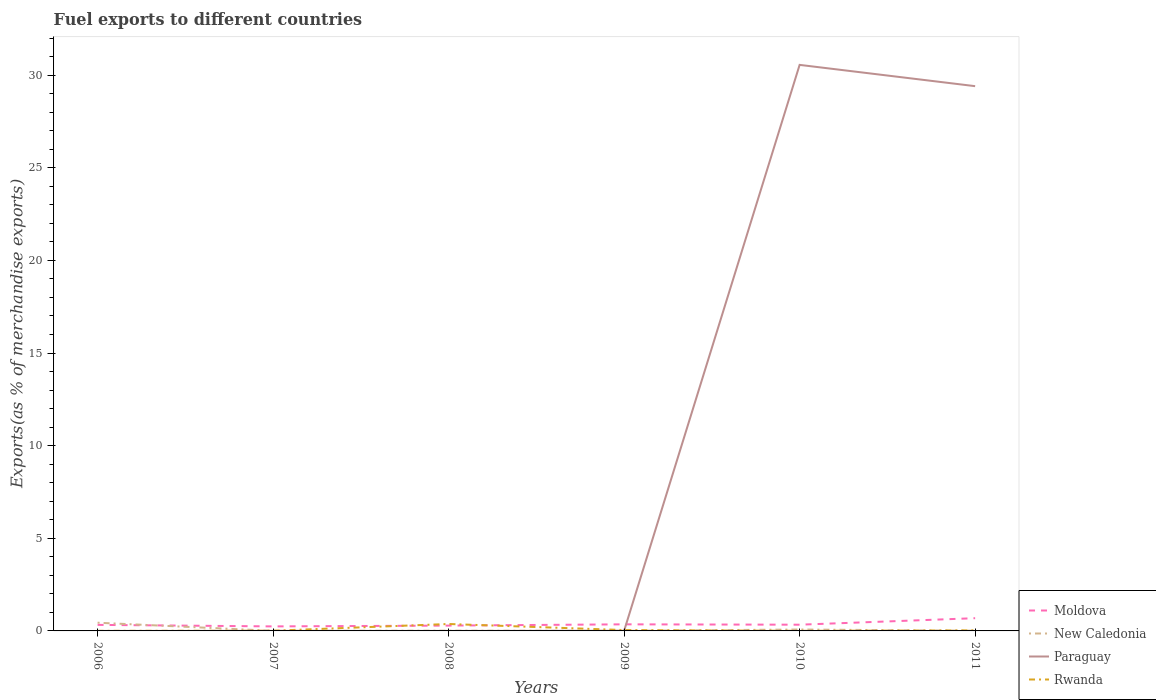Across all years, what is the maximum percentage of exports to different countries in New Caledonia?
Your answer should be compact. 0. What is the total percentage of exports to different countries in New Caledonia in the graph?
Keep it short and to the point. -0.07. What is the difference between the highest and the second highest percentage of exports to different countries in New Caledonia?
Your answer should be compact. 0.44. What is the difference between the highest and the lowest percentage of exports to different countries in Paraguay?
Ensure brevity in your answer.  2. How many lines are there?
Ensure brevity in your answer.  4. How many years are there in the graph?
Your answer should be very brief. 6. What is the difference between two consecutive major ticks on the Y-axis?
Your response must be concise. 5. Does the graph contain grids?
Keep it short and to the point. No. How many legend labels are there?
Your response must be concise. 4. How are the legend labels stacked?
Offer a very short reply. Vertical. What is the title of the graph?
Keep it short and to the point. Fuel exports to different countries. What is the label or title of the X-axis?
Your answer should be very brief. Years. What is the label or title of the Y-axis?
Your response must be concise. Exports(as % of merchandise exports). What is the Exports(as % of merchandise exports) of Moldova in 2006?
Ensure brevity in your answer.  0.33. What is the Exports(as % of merchandise exports) in New Caledonia in 2006?
Give a very brief answer. 0.44. What is the Exports(as % of merchandise exports) in Paraguay in 2006?
Provide a succinct answer. 1.68181738458249e-6. What is the Exports(as % of merchandise exports) of Rwanda in 2006?
Give a very brief answer. 0. What is the Exports(as % of merchandise exports) of Moldova in 2007?
Offer a very short reply. 0.24. What is the Exports(as % of merchandise exports) in New Caledonia in 2007?
Make the answer very short. 0.01. What is the Exports(as % of merchandise exports) in Paraguay in 2007?
Your answer should be compact. 0. What is the Exports(as % of merchandise exports) in Rwanda in 2007?
Give a very brief answer. 0.01. What is the Exports(as % of merchandise exports) of Moldova in 2008?
Ensure brevity in your answer.  0.29. What is the Exports(as % of merchandise exports) of New Caledonia in 2008?
Your answer should be compact. 0.01. What is the Exports(as % of merchandise exports) in Paraguay in 2008?
Keep it short and to the point. 0. What is the Exports(as % of merchandise exports) in Rwanda in 2008?
Offer a very short reply. 0.37. What is the Exports(as % of merchandise exports) of Moldova in 2009?
Provide a succinct answer. 0.36. What is the Exports(as % of merchandise exports) of New Caledonia in 2009?
Keep it short and to the point. 0. What is the Exports(as % of merchandise exports) of Paraguay in 2009?
Your answer should be compact. 0.01. What is the Exports(as % of merchandise exports) in Rwanda in 2009?
Offer a terse response. 0.05. What is the Exports(as % of merchandise exports) of Moldova in 2010?
Make the answer very short. 0.34. What is the Exports(as % of merchandise exports) in New Caledonia in 2010?
Offer a terse response. 0.08. What is the Exports(as % of merchandise exports) in Paraguay in 2010?
Offer a terse response. 30.55. What is the Exports(as % of merchandise exports) of Rwanda in 2010?
Your answer should be compact. 0.01. What is the Exports(as % of merchandise exports) in Moldova in 2011?
Give a very brief answer. 0.69. What is the Exports(as % of merchandise exports) of New Caledonia in 2011?
Make the answer very short. 0.01. What is the Exports(as % of merchandise exports) in Paraguay in 2011?
Offer a very short reply. 29.4. What is the Exports(as % of merchandise exports) of Rwanda in 2011?
Provide a short and direct response. 0.03. Across all years, what is the maximum Exports(as % of merchandise exports) of Moldova?
Keep it short and to the point. 0.69. Across all years, what is the maximum Exports(as % of merchandise exports) in New Caledonia?
Provide a succinct answer. 0.44. Across all years, what is the maximum Exports(as % of merchandise exports) in Paraguay?
Your answer should be compact. 30.55. Across all years, what is the maximum Exports(as % of merchandise exports) of Rwanda?
Ensure brevity in your answer.  0.37. Across all years, what is the minimum Exports(as % of merchandise exports) of Moldova?
Make the answer very short. 0.24. Across all years, what is the minimum Exports(as % of merchandise exports) of New Caledonia?
Keep it short and to the point. 0. Across all years, what is the minimum Exports(as % of merchandise exports) of Paraguay?
Give a very brief answer. 1.68181738458249e-6. Across all years, what is the minimum Exports(as % of merchandise exports) of Rwanda?
Your response must be concise. 0. What is the total Exports(as % of merchandise exports) in Moldova in the graph?
Your answer should be very brief. 2.24. What is the total Exports(as % of merchandise exports) of New Caledonia in the graph?
Ensure brevity in your answer.  0.55. What is the total Exports(as % of merchandise exports) in Paraguay in the graph?
Give a very brief answer. 59.96. What is the total Exports(as % of merchandise exports) in Rwanda in the graph?
Give a very brief answer. 0.47. What is the difference between the Exports(as % of merchandise exports) in Moldova in 2006 and that in 2007?
Offer a very short reply. 0.08. What is the difference between the Exports(as % of merchandise exports) of New Caledonia in 2006 and that in 2007?
Offer a terse response. 0.44. What is the difference between the Exports(as % of merchandise exports) in Paraguay in 2006 and that in 2007?
Your answer should be compact. -0. What is the difference between the Exports(as % of merchandise exports) of Rwanda in 2006 and that in 2007?
Ensure brevity in your answer.  -0.01. What is the difference between the Exports(as % of merchandise exports) of Moldova in 2006 and that in 2008?
Offer a terse response. 0.04. What is the difference between the Exports(as % of merchandise exports) of New Caledonia in 2006 and that in 2008?
Provide a short and direct response. 0.43. What is the difference between the Exports(as % of merchandise exports) of Paraguay in 2006 and that in 2008?
Give a very brief answer. -0. What is the difference between the Exports(as % of merchandise exports) of Rwanda in 2006 and that in 2008?
Provide a succinct answer. -0.37. What is the difference between the Exports(as % of merchandise exports) in Moldova in 2006 and that in 2009?
Your answer should be very brief. -0.03. What is the difference between the Exports(as % of merchandise exports) of New Caledonia in 2006 and that in 2009?
Keep it short and to the point. 0.44. What is the difference between the Exports(as % of merchandise exports) of Paraguay in 2006 and that in 2009?
Your answer should be compact. -0.01. What is the difference between the Exports(as % of merchandise exports) of Rwanda in 2006 and that in 2009?
Give a very brief answer. -0.04. What is the difference between the Exports(as % of merchandise exports) of Moldova in 2006 and that in 2010?
Your answer should be compact. -0.01. What is the difference between the Exports(as % of merchandise exports) of New Caledonia in 2006 and that in 2010?
Keep it short and to the point. 0.37. What is the difference between the Exports(as % of merchandise exports) of Paraguay in 2006 and that in 2010?
Your answer should be compact. -30.55. What is the difference between the Exports(as % of merchandise exports) of Rwanda in 2006 and that in 2010?
Your response must be concise. -0. What is the difference between the Exports(as % of merchandise exports) of Moldova in 2006 and that in 2011?
Offer a very short reply. -0.36. What is the difference between the Exports(as % of merchandise exports) of New Caledonia in 2006 and that in 2011?
Your answer should be very brief. 0.43. What is the difference between the Exports(as % of merchandise exports) in Paraguay in 2006 and that in 2011?
Provide a short and direct response. -29.4. What is the difference between the Exports(as % of merchandise exports) of Rwanda in 2006 and that in 2011?
Offer a very short reply. -0.03. What is the difference between the Exports(as % of merchandise exports) in Moldova in 2007 and that in 2008?
Your answer should be very brief. -0.04. What is the difference between the Exports(as % of merchandise exports) of New Caledonia in 2007 and that in 2008?
Ensure brevity in your answer.  -0.01. What is the difference between the Exports(as % of merchandise exports) in Paraguay in 2007 and that in 2008?
Provide a succinct answer. 0. What is the difference between the Exports(as % of merchandise exports) in Rwanda in 2007 and that in 2008?
Ensure brevity in your answer.  -0.36. What is the difference between the Exports(as % of merchandise exports) in Moldova in 2007 and that in 2009?
Your response must be concise. -0.11. What is the difference between the Exports(as % of merchandise exports) of New Caledonia in 2007 and that in 2009?
Offer a terse response. 0. What is the difference between the Exports(as % of merchandise exports) in Paraguay in 2007 and that in 2009?
Give a very brief answer. -0.01. What is the difference between the Exports(as % of merchandise exports) in Rwanda in 2007 and that in 2009?
Offer a very short reply. -0.04. What is the difference between the Exports(as % of merchandise exports) in Moldova in 2007 and that in 2010?
Your response must be concise. -0.09. What is the difference between the Exports(as % of merchandise exports) in New Caledonia in 2007 and that in 2010?
Make the answer very short. -0.07. What is the difference between the Exports(as % of merchandise exports) in Paraguay in 2007 and that in 2010?
Offer a terse response. -30.55. What is the difference between the Exports(as % of merchandise exports) of Rwanda in 2007 and that in 2010?
Your answer should be compact. 0.01. What is the difference between the Exports(as % of merchandise exports) of Moldova in 2007 and that in 2011?
Your answer should be compact. -0.44. What is the difference between the Exports(as % of merchandise exports) in New Caledonia in 2007 and that in 2011?
Offer a very short reply. -0.01. What is the difference between the Exports(as % of merchandise exports) in Paraguay in 2007 and that in 2011?
Make the answer very short. -29.4. What is the difference between the Exports(as % of merchandise exports) in Rwanda in 2007 and that in 2011?
Provide a succinct answer. -0.02. What is the difference between the Exports(as % of merchandise exports) in Moldova in 2008 and that in 2009?
Your response must be concise. -0.07. What is the difference between the Exports(as % of merchandise exports) in New Caledonia in 2008 and that in 2009?
Offer a terse response. 0.01. What is the difference between the Exports(as % of merchandise exports) of Paraguay in 2008 and that in 2009?
Your answer should be compact. -0.01. What is the difference between the Exports(as % of merchandise exports) of Rwanda in 2008 and that in 2009?
Offer a very short reply. 0.33. What is the difference between the Exports(as % of merchandise exports) in Moldova in 2008 and that in 2010?
Your answer should be very brief. -0.05. What is the difference between the Exports(as % of merchandise exports) of New Caledonia in 2008 and that in 2010?
Give a very brief answer. -0.07. What is the difference between the Exports(as % of merchandise exports) in Paraguay in 2008 and that in 2010?
Your response must be concise. -30.55. What is the difference between the Exports(as % of merchandise exports) in Rwanda in 2008 and that in 2010?
Your answer should be very brief. 0.37. What is the difference between the Exports(as % of merchandise exports) of Moldova in 2008 and that in 2011?
Provide a short and direct response. -0.4. What is the difference between the Exports(as % of merchandise exports) in New Caledonia in 2008 and that in 2011?
Your answer should be very brief. 0. What is the difference between the Exports(as % of merchandise exports) of Paraguay in 2008 and that in 2011?
Make the answer very short. -29.4. What is the difference between the Exports(as % of merchandise exports) of Rwanda in 2008 and that in 2011?
Provide a succinct answer. 0.34. What is the difference between the Exports(as % of merchandise exports) in Moldova in 2009 and that in 2010?
Give a very brief answer. 0.02. What is the difference between the Exports(as % of merchandise exports) of New Caledonia in 2009 and that in 2010?
Make the answer very short. -0.07. What is the difference between the Exports(as % of merchandise exports) in Paraguay in 2009 and that in 2010?
Keep it short and to the point. -30.54. What is the difference between the Exports(as % of merchandise exports) in Rwanda in 2009 and that in 2010?
Offer a very short reply. 0.04. What is the difference between the Exports(as % of merchandise exports) in Moldova in 2009 and that in 2011?
Ensure brevity in your answer.  -0.33. What is the difference between the Exports(as % of merchandise exports) of New Caledonia in 2009 and that in 2011?
Ensure brevity in your answer.  -0.01. What is the difference between the Exports(as % of merchandise exports) of Paraguay in 2009 and that in 2011?
Ensure brevity in your answer.  -29.39. What is the difference between the Exports(as % of merchandise exports) of Rwanda in 2009 and that in 2011?
Offer a terse response. 0.02. What is the difference between the Exports(as % of merchandise exports) in Moldova in 2010 and that in 2011?
Give a very brief answer. -0.35. What is the difference between the Exports(as % of merchandise exports) in New Caledonia in 2010 and that in 2011?
Offer a terse response. 0.07. What is the difference between the Exports(as % of merchandise exports) of Paraguay in 2010 and that in 2011?
Provide a short and direct response. 1.15. What is the difference between the Exports(as % of merchandise exports) in Rwanda in 2010 and that in 2011?
Your answer should be very brief. -0.03. What is the difference between the Exports(as % of merchandise exports) of Moldova in 2006 and the Exports(as % of merchandise exports) of New Caledonia in 2007?
Offer a terse response. 0.32. What is the difference between the Exports(as % of merchandise exports) of Moldova in 2006 and the Exports(as % of merchandise exports) of Paraguay in 2007?
Your answer should be compact. 0.33. What is the difference between the Exports(as % of merchandise exports) in Moldova in 2006 and the Exports(as % of merchandise exports) in Rwanda in 2007?
Provide a short and direct response. 0.32. What is the difference between the Exports(as % of merchandise exports) in New Caledonia in 2006 and the Exports(as % of merchandise exports) in Paraguay in 2007?
Your answer should be compact. 0.44. What is the difference between the Exports(as % of merchandise exports) in New Caledonia in 2006 and the Exports(as % of merchandise exports) in Rwanda in 2007?
Ensure brevity in your answer.  0.43. What is the difference between the Exports(as % of merchandise exports) in Paraguay in 2006 and the Exports(as % of merchandise exports) in Rwanda in 2007?
Your answer should be very brief. -0.01. What is the difference between the Exports(as % of merchandise exports) of Moldova in 2006 and the Exports(as % of merchandise exports) of New Caledonia in 2008?
Make the answer very short. 0.32. What is the difference between the Exports(as % of merchandise exports) in Moldova in 2006 and the Exports(as % of merchandise exports) in Paraguay in 2008?
Give a very brief answer. 0.33. What is the difference between the Exports(as % of merchandise exports) in Moldova in 2006 and the Exports(as % of merchandise exports) in Rwanda in 2008?
Your answer should be compact. -0.05. What is the difference between the Exports(as % of merchandise exports) in New Caledonia in 2006 and the Exports(as % of merchandise exports) in Paraguay in 2008?
Offer a terse response. 0.44. What is the difference between the Exports(as % of merchandise exports) in New Caledonia in 2006 and the Exports(as % of merchandise exports) in Rwanda in 2008?
Your answer should be very brief. 0.07. What is the difference between the Exports(as % of merchandise exports) of Paraguay in 2006 and the Exports(as % of merchandise exports) of Rwanda in 2008?
Provide a short and direct response. -0.37. What is the difference between the Exports(as % of merchandise exports) in Moldova in 2006 and the Exports(as % of merchandise exports) in New Caledonia in 2009?
Your response must be concise. 0.32. What is the difference between the Exports(as % of merchandise exports) of Moldova in 2006 and the Exports(as % of merchandise exports) of Paraguay in 2009?
Your answer should be compact. 0.32. What is the difference between the Exports(as % of merchandise exports) in Moldova in 2006 and the Exports(as % of merchandise exports) in Rwanda in 2009?
Your answer should be compact. 0.28. What is the difference between the Exports(as % of merchandise exports) in New Caledonia in 2006 and the Exports(as % of merchandise exports) in Paraguay in 2009?
Offer a terse response. 0.43. What is the difference between the Exports(as % of merchandise exports) in New Caledonia in 2006 and the Exports(as % of merchandise exports) in Rwanda in 2009?
Offer a very short reply. 0.4. What is the difference between the Exports(as % of merchandise exports) of Paraguay in 2006 and the Exports(as % of merchandise exports) of Rwanda in 2009?
Your response must be concise. -0.05. What is the difference between the Exports(as % of merchandise exports) of Moldova in 2006 and the Exports(as % of merchandise exports) of New Caledonia in 2010?
Offer a very short reply. 0.25. What is the difference between the Exports(as % of merchandise exports) in Moldova in 2006 and the Exports(as % of merchandise exports) in Paraguay in 2010?
Provide a short and direct response. -30.22. What is the difference between the Exports(as % of merchandise exports) in Moldova in 2006 and the Exports(as % of merchandise exports) in Rwanda in 2010?
Give a very brief answer. 0.32. What is the difference between the Exports(as % of merchandise exports) of New Caledonia in 2006 and the Exports(as % of merchandise exports) of Paraguay in 2010?
Offer a terse response. -30.11. What is the difference between the Exports(as % of merchandise exports) in New Caledonia in 2006 and the Exports(as % of merchandise exports) in Rwanda in 2010?
Make the answer very short. 0.44. What is the difference between the Exports(as % of merchandise exports) in Paraguay in 2006 and the Exports(as % of merchandise exports) in Rwanda in 2010?
Your answer should be very brief. -0.01. What is the difference between the Exports(as % of merchandise exports) in Moldova in 2006 and the Exports(as % of merchandise exports) in New Caledonia in 2011?
Your answer should be compact. 0.32. What is the difference between the Exports(as % of merchandise exports) of Moldova in 2006 and the Exports(as % of merchandise exports) of Paraguay in 2011?
Your answer should be compact. -29.08. What is the difference between the Exports(as % of merchandise exports) of Moldova in 2006 and the Exports(as % of merchandise exports) of Rwanda in 2011?
Offer a very short reply. 0.3. What is the difference between the Exports(as % of merchandise exports) in New Caledonia in 2006 and the Exports(as % of merchandise exports) in Paraguay in 2011?
Your response must be concise. -28.96. What is the difference between the Exports(as % of merchandise exports) in New Caledonia in 2006 and the Exports(as % of merchandise exports) in Rwanda in 2011?
Give a very brief answer. 0.41. What is the difference between the Exports(as % of merchandise exports) of Paraguay in 2006 and the Exports(as % of merchandise exports) of Rwanda in 2011?
Provide a succinct answer. -0.03. What is the difference between the Exports(as % of merchandise exports) of Moldova in 2007 and the Exports(as % of merchandise exports) of New Caledonia in 2008?
Make the answer very short. 0.23. What is the difference between the Exports(as % of merchandise exports) of Moldova in 2007 and the Exports(as % of merchandise exports) of Paraguay in 2008?
Make the answer very short. 0.24. What is the difference between the Exports(as % of merchandise exports) of Moldova in 2007 and the Exports(as % of merchandise exports) of Rwanda in 2008?
Ensure brevity in your answer.  -0.13. What is the difference between the Exports(as % of merchandise exports) of New Caledonia in 2007 and the Exports(as % of merchandise exports) of Paraguay in 2008?
Provide a short and direct response. 0.01. What is the difference between the Exports(as % of merchandise exports) in New Caledonia in 2007 and the Exports(as % of merchandise exports) in Rwanda in 2008?
Keep it short and to the point. -0.37. What is the difference between the Exports(as % of merchandise exports) in Paraguay in 2007 and the Exports(as % of merchandise exports) in Rwanda in 2008?
Offer a terse response. -0.37. What is the difference between the Exports(as % of merchandise exports) in Moldova in 2007 and the Exports(as % of merchandise exports) in New Caledonia in 2009?
Keep it short and to the point. 0.24. What is the difference between the Exports(as % of merchandise exports) in Moldova in 2007 and the Exports(as % of merchandise exports) in Paraguay in 2009?
Offer a terse response. 0.24. What is the difference between the Exports(as % of merchandise exports) of Moldova in 2007 and the Exports(as % of merchandise exports) of Rwanda in 2009?
Make the answer very short. 0.2. What is the difference between the Exports(as % of merchandise exports) in New Caledonia in 2007 and the Exports(as % of merchandise exports) in Paraguay in 2009?
Your response must be concise. -0. What is the difference between the Exports(as % of merchandise exports) of New Caledonia in 2007 and the Exports(as % of merchandise exports) of Rwanda in 2009?
Ensure brevity in your answer.  -0.04. What is the difference between the Exports(as % of merchandise exports) in Paraguay in 2007 and the Exports(as % of merchandise exports) in Rwanda in 2009?
Provide a succinct answer. -0.05. What is the difference between the Exports(as % of merchandise exports) of Moldova in 2007 and the Exports(as % of merchandise exports) of New Caledonia in 2010?
Provide a short and direct response. 0.17. What is the difference between the Exports(as % of merchandise exports) of Moldova in 2007 and the Exports(as % of merchandise exports) of Paraguay in 2010?
Ensure brevity in your answer.  -30.31. What is the difference between the Exports(as % of merchandise exports) in Moldova in 2007 and the Exports(as % of merchandise exports) in Rwanda in 2010?
Keep it short and to the point. 0.24. What is the difference between the Exports(as % of merchandise exports) of New Caledonia in 2007 and the Exports(as % of merchandise exports) of Paraguay in 2010?
Your answer should be compact. -30.55. What is the difference between the Exports(as % of merchandise exports) in New Caledonia in 2007 and the Exports(as % of merchandise exports) in Rwanda in 2010?
Offer a very short reply. -0. What is the difference between the Exports(as % of merchandise exports) of Paraguay in 2007 and the Exports(as % of merchandise exports) of Rwanda in 2010?
Your answer should be compact. -0. What is the difference between the Exports(as % of merchandise exports) of Moldova in 2007 and the Exports(as % of merchandise exports) of New Caledonia in 2011?
Provide a short and direct response. 0.23. What is the difference between the Exports(as % of merchandise exports) of Moldova in 2007 and the Exports(as % of merchandise exports) of Paraguay in 2011?
Make the answer very short. -29.16. What is the difference between the Exports(as % of merchandise exports) of Moldova in 2007 and the Exports(as % of merchandise exports) of Rwanda in 2011?
Keep it short and to the point. 0.21. What is the difference between the Exports(as % of merchandise exports) of New Caledonia in 2007 and the Exports(as % of merchandise exports) of Paraguay in 2011?
Ensure brevity in your answer.  -29.4. What is the difference between the Exports(as % of merchandise exports) of New Caledonia in 2007 and the Exports(as % of merchandise exports) of Rwanda in 2011?
Your answer should be compact. -0.03. What is the difference between the Exports(as % of merchandise exports) in Paraguay in 2007 and the Exports(as % of merchandise exports) in Rwanda in 2011?
Offer a terse response. -0.03. What is the difference between the Exports(as % of merchandise exports) in Moldova in 2008 and the Exports(as % of merchandise exports) in New Caledonia in 2009?
Your answer should be compact. 0.28. What is the difference between the Exports(as % of merchandise exports) in Moldova in 2008 and the Exports(as % of merchandise exports) in Paraguay in 2009?
Provide a short and direct response. 0.28. What is the difference between the Exports(as % of merchandise exports) of Moldova in 2008 and the Exports(as % of merchandise exports) of Rwanda in 2009?
Keep it short and to the point. 0.24. What is the difference between the Exports(as % of merchandise exports) in New Caledonia in 2008 and the Exports(as % of merchandise exports) in Paraguay in 2009?
Make the answer very short. 0. What is the difference between the Exports(as % of merchandise exports) of New Caledonia in 2008 and the Exports(as % of merchandise exports) of Rwanda in 2009?
Offer a terse response. -0.04. What is the difference between the Exports(as % of merchandise exports) of Paraguay in 2008 and the Exports(as % of merchandise exports) of Rwanda in 2009?
Provide a succinct answer. -0.05. What is the difference between the Exports(as % of merchandise exports) of Moldova in 2008 and the Exports(as % of merchandise exports) of New Caledonia in 2010?
Your answer should be compact. 0.21. What is the difference between the Exports(as % of merchandise exports) in Moldova in 2008 and the Exports(as % of merchandise exports) in Paraguay in 2010?
Your answer should be very brief. -30.26. What is the difference between the Exports(as % of merchandise exports) of Moldova in 2008 and the Exports(as % of merchandise exports) of Rwanda in 2010?
Give a very brief answer. 0.28. What is the difference between the Exports(as % of merchandise exports) in New Caledonia in 2008 and the Exports(as % of merchandise exports) in Paraguay in 2010?
Your answer should be very brief. -30.54. What is the difference between the Exports(as % of merchandise exports) in New Caledonia in 2008 and the Exports(as % of merchandise exports) in Rwanda in 2010?
Make the answer very short. 0.01. What is the difference between the Exports(as % of merchandise exports) of Paraguay in 2008 and the Exports(as % of merchandise exports) of Rwanda in 2010?
Ensure brevity in your answer.  -0.01. What is the difference between the Exports(as % of merchandise exports) of Moldova in 2008 and the Exports(as % of merchandise exports) of New Caledonia in 2011?
Your response must be concise. 0.28. What is the difference between the Exports(as % of merchandise exports) in Moldova in 2008 and the Exports(as % of merchandise exports) in Paraguay in 2011?
Your answer should be very brief. -29.11. What is the difference between the Exports(as % of merchandise exports) of Moldova in 2008 and the Exports(as % of merchandise exports) of Rwanda in 2011?
Give a very brief answer. 0.26. What is the difference between the Exports(as % of merchandise exports) in New Caledonia in 2008 and the Exports(as % of merchandise exports) in Paraguay in 2011?
Your answer should be very brief. -29.39. What is the difference between the Exports(as % of merchandise exports) in New Caledonia in 2008 and the Exports(as % of merchandise exports) in Rwanda in 2011?
Give a very brief answer. -0.02. What is the difference between the Exports(as % of merchandise exports) in Paraguay in 2008 and the Exports(as % of merchandise exports) in Rwanda in 2011?
Provide a short and direct response. -0.03. What is the difference between the Exports(as % of merchandise exports) of Moldova in 2009 and the Exports(as % of merchandise exports) of New Caledonia in 2010?
Provide a succinct answer. 0.28. What is the difference between the Exports(as % of merchandise exports) of Moldova in 2009 and the Exports(as % of merchandise exports) of Paraguay in 2010?
Keep it short and to the point. -30.2. What is the difference between the Exports(as % of merchandise exports) in Moldova in 2009 and the Exports(as % of merchandise exports) in Rwanda in 2010?
Offer a terse response. 0.35. What is the difference between the Exports(as % of merchandise exports) of New Caledonia in 2009 and the Exports(as % of merchandise exports) of Paraguay in 2010?
Your response must be concise. -30.55. What is the difference between the Exports(as % of merchandise exports) in New Caledonia in 2009 and the Exports(as % of merchandise exports) in Rwanda in 2010?
Give a very brief answer. -0. What is the difference between the Exports(as % of merchandise exports) in Paraguay in 2009 and the Exports(as % of merchandise exports) in Rwanda in 2010?
Provide a short and direct response. 0. What is the difference between the Exports(as % of merchandise exports) of Moldova in 2009 and the Exports(as % of merchandise exports) of New Caledonia in 2011?
Offer a very short reply. 0.35. What is the difference between the Exports(as % of merchandise exports) of Moldova in 2009 and the Exports(as % of merchandise exports) of Paraguay in 2011?
Give a very brief answer. -29.05. What is the difference between the Exports(as % of merchandise exports) in Moldova in 2009 and the Exports(as % of merchandise exports) in Rwanda in 2011?
Your answer should be very brief. 0.33. What is the difference between the Exports(as % of merchandise exports) in New Caledonia in 2009 and the Exports(as % of merchandise exports) in Paraguay in 2011?
Offer a very short reply. -29.4. What is the difference between the Exports(as % of merchandise exports) in New Caledonia in 2009 and the Exports(as % of merchandise exports) in Rwanda in 2011?
Give a very brief answer. -0.03. What is the difference between the Exports(as % of merchandise exports) of Paraguay in 2009 and the Exports(as % of merchandise exports) of Rwanda in 2011?
Give a very brief answer. -0.02. What is the difference between the Exports(as % of merchandise exports) in Moldova in 2010 and the Exports(as % of merchandise exports) in New Caledonia in 2011?
Ensure brevity in your answer.  0.33. What is the difference between the Exports(as % of merchandise exports) in Moldova in 2010 and the Exports(as % of merchandise exports) in Paraguay in 2011?
Keep it short and to the point. -29.07. What is the difference between the Exports(as % of merchandise exports) in Moldova in 2010 and the Exports(as % of merchandise exports) in Rwanda in 2011?
Keep it short and to the point. 0.31. What is the difference between the Exports(as % of merchandise exports) of New Caledonia in 2010 and the Exports(as % of merchandise exports) of Paraguay in 2011?
Your answer should be very brief. -29.33. What is the difference between the Exports(as % of merchandise exports) in New Caledonia in 2010 and the Exports(as % of merchandise exports) in Rwanda in 2011?
Your answer should be very brief. 0.05. What is the difference between the Exports(as % of merchandise exports) in Paraguay in 2010 and the Exports(as % of merchandise exports) in Rwanda in 2011?
Ensure brevity in your answer.  30.52. What is the average Exports(as % of merchandise exports) in Moldova per year?
Ensure brevity in your answer.  0.37. What is the average Exports(as % of merchandise exports) of New Caledonia per year?
Keep it short and to the point. 0.09. What is the average Exports(as % of merchandise exports) in Paraguay per year?
Keep it short and to the point. 9.99. What is the average Exports(as % of merchandise exports) in Rwanda per year?
Offer a very short reply. 0.08. In the year 2006, what is the difference between the Exports(as % of merchandise exports) of Moldova and Exports(as % of merchandise exports) of New Caledonia?
Offer a terse response. -0.12. In the year 2006, what is the difference between the Exports(as % of merchandise exports) in Moldova and Exports(as % of merchandise exports) in Paraguay?
Your answer should be compact. 0.33. In the year 2006, what is the difference between the Exports(as % of merchandise exports) of Moldova and Exports(as % of merchandise exports) of Rwanda?
Give a very brief answer. 0.32. In the year 2006, what is the difference between the Exports(as % of merchandise exports) in New Caledonia and Exports(as % of merchandise exports) in Paraguay?
Keep it short and to the point. 0.44. In the year 2006, what is the difference between the Exports(as % of merchandise exports) in New Caledonia and Exports(as % of merchandise exports) in Rwanda?
Provide a short and direct response. 0.44. In the year 2006, what is the difference between the Exports(as % of merchandise exports) of Paraguay and Exports(as % of merchandise exports) of Rwanda?
Your answer should be very brief. -0. In the year 2007, what is the difference between the Exports(as % of merchandise exports) in Moldova and Exports(as % of merchandise exports) in New Caledonia?
Make the answer very short. 0.24. In the year 2007, what is the difference between the Exports(as % of merchandise exports) of Moldova and Exports(as % of merchandise exports) of Paraguay?
Your answer should be compact. 0.24. In the year 2007, what is the difference between the Exports(as % of merchandise exports) of Moldova and Exports(as % of merchandise exports) of Rwanda?
Give a very brief answer. 0.23. In the year 2007, what is the difference between the Exports(as % of merchandise exports) of New Caledonia and Exports(as % of merchandise exports) of Paraguay?
Provide a short and direct response. 0. In the year 2007, what is the difference between the Exports(as % of merchandise exports) in New Caledonia and Exports(as % of merchandise exports) in Rwanda?
Ensure brevity in your answer.  -0.01. In the year 2007, what is the difference between the Exports(as % of merchandise exports) in Paraguay and Exports(as % of merchandise exports) in Rwanda?
Ensure brevity in your answer.  -0.01. In the year 2008, what is the difference between the Exports(as % of merchandise exports) of Moldova and Exports(as % of merchandise exports) of New Caledonia?
Ensure brevity in your answer.  0.28. In the year 2008, what is the difference between the Exports(as % of merchandise exports) of Moldova and Exports(as % of merchandise exports) of Paraguay?
Your answer should be compact. 0.29. In the year 2008, what is the difference between the Exports(as % of merchandise exports) of Moldova and Exports(as % of merchandise exports) of Rwanda?
Your response must be concise. -0.09. In the year 2008, what is the difference between the Exports(as % of merchandise exports) of New Caledonia and Exports(as % of merchandise exports) of Paraguay?
Ensure brevity in your answer.  0.01. In the year 2008, what is the difference between the Exports(as % of merchandise exports) in New Caledonia and Exports(as % of merchandise exports) in Rwanda?
Your response must be concise. -0.36. In the year 2008, what is the difference between the Exports(as % of merchandise exports) of Paraguay and Exports(as % of merchandise exports) of Rwanda?
Offer a terse response. -0.37. In the year 2009, what is the difference between the Exports(as % of merchandise exports) of Moldova and Exports(as % of merchandise exports) of New Caledonia?
Give a very brief answer. 0.35. In the year 2009, what is the difference between the Exports(as % of merchandise exports) of Moldova and Exports(as % of merchandise exports) of Paraguay?
Ensure brevity in your answer.  0.35. In the year 2009, what is the difference between the Exports(as % of merchandise exports) of Moldova and Exports(as % of merchandise exports) of Rwanda?
Provide a short and direct response. 0.31. In the year 2009, what is the difference between the Exports(as % of merchandise exports) of New Caledonia and Exports(as % of merchandise exports) of Paraguay?
Offer a very short reply. -0. In the year 2009, what is the difference between the Exports(as % of merchandise exports) of New Caledonia and Exports(as % of merchandise exports) of Rwanda?
Provide a succinct answer. -0.04. In the year 2009, what is the difference between the Exports(as % of merchandise exports) in Paraguay and Exports(as % of merchandise exports) in Rwanda?
Keep it short and to the point. -0.04. In the year 2010, what is the difference between the Exports(as % of merchandise exports) in Moldova and Exports(as % of merchandise exports) in New Caledonia?
Make the answer very short. 0.26. In the year 2010, what is the difference between the Exports(as % of merchandise exports) of Moldova and Exports(as % of merchandise exports) of Paraguay?
Your response must be concise. -30.22. In the year 2010, what is the difference between the Exports(as % of merchandise exports) in Moldova and Exports(as % of merchandise exports) in Rwanda?
Provide a short and direct response. 0.33. In the year 2010, what is the difference between the Exports(as % of merchandise exports) of New Caledonia and Exports(as % of merchandise exports) of Paraguay?
Make the answer very short. -30.48. In the year 2010, what is the difference between the Exports(as % of merchandise exports) of New Caledonia and Exports(as % of merchandise exports) of Rwanda?
Your response must be concise. 0.07. In the year 2010, what is the difference between the Exports(as % of merchandise exports) in Paraguay and Exports(as % of merchandise exports) in Rwanda?
Provide a succinct answer. 30.55. In the year 2011, what is the difference between the Exports(as % of merchandise exports) in Moldova and Exports(as % of merchandise exports) in New Caledonia?
Make the answer very short. 0.68. In the year 2011, what is the difference between the Exports(as % of merchandise exports) in Moldova and Exports(as % of merchandise exports) in Paraguay?
Offer a very short reply. -28.71. In the year 2011, what is the difference between the Exports(as % of merchandise exports) of Moldova and Exports(as % of merchandise exports) of Rwanda?
Provide a succinct answer. 0.66. In the year 2011, what is the difference between the Exports(as % of merchandise exports) in New Caledonia and Exports(as % of merchandise exports) in Paraguay?
Give a very brief answer. -29.39. In the year 2011, what is the difference between the Exports(as % of merchandise exports) in New Caledonia and Exports(as % of merchandise exports) in Rwanda?
Keep it short and to the point. -0.02. In the year 2011, what is the difference between the Exports(as % of merchandise exports) of Paraguay and Exports(as % of merchandise exports) of Rwanda?
Your answer should be compact. 29.37. What is the ratio of the Exports(as % of merchandise exports) of Moldova in 2006 to that in 2007?
Give a very brief answer. 1.34. What is the ratio of the Exports(as % of merchandise exports) in New Caledonia in 2006 to that in 2007?
Offer a very short reply. 85.23. What is the ratio of the Exports(as % of merchandise exports) of Paraguay in 2006 to that in 2007?
Provide a succinct answer. 0. What is the ratio of the Exports(as % of merchandise exports) in Rwanda in 2006 to that in 2007?
Offer a terse response. 0.36. What is the ratio of the Exports(as % of merchandise exports) of Moldova in 2006 to that in 2008?
Your answer should be compact. 1.13. What is the ratio of the Exports(as % of merchandise exports) in New Caledonia in 2006 to that in 2008?
Your response must be concise. 39.52. What is the ratio of the Exports(as % of merchandise exports) in Paraguay in 2006 to that in 2008?
Your answer should be compact. 0.01. What is the ratio of the Exports(as % of merchandise exports) in Rwanda in 2006 to that in 2008?
Your answer should be very brief. 0.01. What is the ratio of the Exports(as % of merchandise exports) in Moldova in 2006 to that in 2009?
Your answer should be very brief. 0.92. What is the ratio of the Exports(as % of merchandise exports) of New Caledonia in 2006 to that in 2009?
Your response must be concise. 90.88. What is the ratio of the Exports(as % of merchandise exports) of Rwanda in 2006 to that in 2009?
Your response must be concise. 0.08. What is the ratio of the Exports(as % of merchandise exports) of Moldova in 2006 to that in 2010?
Provide a succinct answer. 0.97. What is the ratio of the Exports(as % of merchandise exports) of New Caledonia in 2006 to that in 2010?
Offer a very short reply. 5.81. What is the ratio of the Exports(as % of merchandise exports) in Paraguay in 2006 to that in 2010?
Make the answer very short. 0. What is the ratio of the Exports(as % of merchandise exports) of Rwanda in 2006 to that in 2010?
Offer a terse response. 0.74. What is the ratio of the Exports(as % of merchandise exports) of Moldova in 2006 to that in 2011?
Offer a terse response. 0.47. What is the ratio of the Exports(as % of merchandise exports) in New Caledonia in 2006 to that in 2011?
Provide a succinct answer. 42.34. What is the ratio of the Exports(as % of merchandise exports) in Paraguay in 2006 to that in 2011?
Give a very brief answer. 0. What is the ratio of the Exports(as % of merchandise exports) of Rwanda in 2006 to that in 2011?
Offer a very short reply. 0.13. What is the ratio of the Exports(as % of merchandise exports) of Moldova in 2007 to that in 2008?
Your answer should be very brief. 0.85. What is the ratio of the Exports(as % of merchandise exports) of New Caledonia in 2007 to that in 2008?
Keep it short and to the point. 0.46. What is the ratio of the Exports(as % of merchandise exports) of Paraguay in 2007 to that in 2008?
Offer a terse response. 4.21. What is the ratio of the Exports(as % of merchandise exports) in Rwanda in 2007 to that in 2008?
Your answer should be compact. 0.03. What is the ratio of the Exports(as % of merchandise exports) of Moldova in 2007 to that in 2009?
Your answer should be very brief. 0.69. What is the ratio of the Exports(as % of merchandise exports) of New Caledonia in 2007 to that in 2009?
Make the answer very short. 1.07. What is the ratio of the Exports(as % of merchandise exports) in Paraguay in 2007 to that in 2009?
Provide a short and direct response. 0.11. What is the ratio of the Exports(as % of merchandise exports) of Rwanda in 2007 to that in 2009?
Your answer should be compact. 0.23. What is the ratio of the Exports(as % of merchandise exports) in Moldova in 2007 to that in 2010?
Give a very brief answer. 0.73. What is the ratio of the Exports(as % of merchandise exports) in New Caledonia in 2007 to that in 2010?
Ensure brevity in your answer.  0.07. What is the ratio of the Exports(as % of merchandise exports) in Rwanda in 2007 to that in 2010?
Your answer should be compact. 2.07. What is the ratio of the Exports(as % of merchandise exports) of Moldova in 2007 to that in 2011?
Make the answer very short. 0.35. What is the ratio of the Exports(as % of merchandise exports) in New Caledonia in 2007 to that in 2011?
Provide a short and direct response. 0.5. What is the ratio of the Exports(as % of merchandise exports) of Paraguay in 2007 to that in 2011?
Your response must be concise. 0. What is the ratio of the Exports(as % of merchandise exports) of Rwanda in 2007 to that in 2011?
Ensure brevity in your answer.  0.36. What is the ratio of the Exports(as % of merchandise exports) in Moldova in 2008 to that in 2009?
Offer a terse response. 0.81. What is the ratio of the Exports(as % of merchandise exports) of New Caledonia in 2008 to that in 2009?
Your answer should be compact. 2.3. What is the ratio of the Exports(as % of merchandise exports) in Paraguay in 2008 to that in 2009?
Your response must be concise. 0.03. What is the ratio of the Exports(as % of merchandise exports) in Rwanda in 2008 to that in 2009?
Offer a very short reply. 8.01. What is the ratio of the Exports(as % of merchandise exports) in Moldova in 2008 to that in 2010?
Provide a succinct answer. 0.86. What is the ratio of the Exports(as % of merchandise exports) of New Caledonia in 2008 to that in 2010?
Make the answer very short. 0.15. What is the ratio of the Exports(as % of merchandise exports) in Rwanda in 2008 to that in 2010?
Your answer should be compact. 71.41. What is the ratio of the Exports(as % of merchandise exports) of Moldova in 2008 to that in 2011?
Provide a short and direct response. 0.42. What is the ratio of the Exports(as % of merchandise exports) of New Caledonia in 2008 to that in 2011?
Ensure brevity in your answer.  1.07. What is the ratio of the Exports(as % of merchandise exports) in Paraguay in 2008 to that in 2011?
Your answer should be very brief. 0. What is the ratio of the Exports(as % of merchandise exports) in Rwanda in 2008 to that in 2011?
Your answer should be compact. 12.3. What is the ratio of the Exports(as % of merchandise exports) of Moldova in 2009 to that in 2010?
Ensure brevity in your answer.  1.06. What is the ratio of the Exports(as % of merchandise exports) in New Caledonia in 2009 to that in 2010?
Offer a very short reply. 0.06. What is the ratio of the Exports(as % of merchandise exports) in Rwanda in 2009 to that in 2010?
Your answer should be very brief. 8.91. What is the ratio of the Exports(as % of merchandise exports) of Moldova in 2009 to that in 2011?
Your answer should be very brief. 0.52. What is the ratio of the Exports(as % of merchandise exports) in New Caledonia in 2009 to that in 2011?
Offer a very short reply. 0.47. What is the ratio of the Exports(as % of merchandise exports) of Paraguay in 2009 to that in 2011?
Your answer should be compact. 0. What is the ratio of the Exports(as % of merchandise exports) in Rwanda in 2009 to that in 2011?
Your answer should be compact. 1.54. What is the ratio of the Exports(as % of merchandise exports) of Moldova in 2010 to that in 2011?
Keep it short and to the point. 0.49. What is the ratio of the Exports(as % of merchandise exports) of New Caledonia in 2010 to that in 2011?
Your answer should be very brief. 7.28. What is the ratio of the Exports(as % of merchandise exports) in Paraguay in 2010 to that in 2011?
Keep it short and to the point. 1.04. What is the ratio of the Exports(as % of merchandise exports) in Rwanda in 2010 to that in 2011?
Your response must be concise. 0.17. What is the difference between the highest and the second highest Exports(as % of merchandise exports) in Moldova?
Your answer should be very brief. 0.33. What is the difference between the highest and the second highest Exports(as % of merchandise exports) of New Caledonia?
Your response must be concise. 0.37. What is the difference between the highest and the second highest Exports(as % of merchandise exports) in Paraguay?
Provide a succinct answer. 1.15. What is the difference between the highest and the second highest Exports(as % of merchandise exports) of Rwanda?
Provide a short and direct response. 0.33. What is the difference between the highest and the lowest Exports(as % of merchandise exports) of Moldova?
Your answer should be very brief. 0.44. What is the difference between the highest and the lowest Exports(as % of merchandise exports) of New Caledonia?
Give a very brief answer. 0.44. What is the difference between the highest and the lowest Exports(as % of merchandise exports) in Paraguay?
Offer a terse response. 30.55. What is the difference between the highest and the lowest Exports(as % of merchandise exports) in Rwanda?
Make the answer very short. 0.37. 